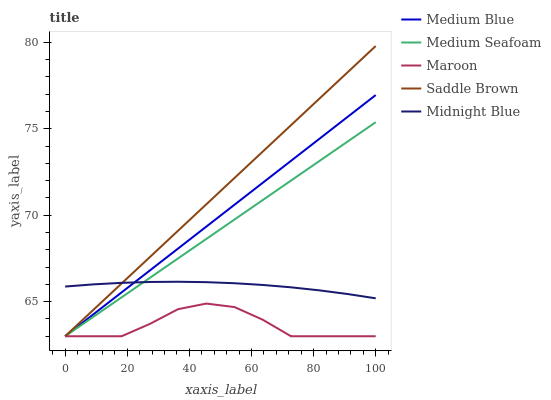Does Maroon have the minimum area under the curve?
Answer yes or no. Yes. Does Saddle Brown have the maximum area under the curve?
Answer yes or no. Yes. Does Medium Blue have the minimum area under the curve?
Answer yes or no. No. Does Medium Blue have the maximum area under the curve?
Answer yes or no. No. Is Medium Seafoam the smoothest?
Answer yes or no. Yes. Is Maroon the roughest?
Answer yes or no. Yes. Is Medium Blue the smoothest?
Answer yes or no. No. Is Medium Blue the roughest?
Answer yes or no. No. Does Saddle Brown have the highest value?
Answer yes or no. Yes. Does Medium Blue have the highest value?
Answer yes or no. No. Is Maroon less than Midnight Blue?
Answer yes or no. Yes. Is Midnight Blue greater than Maroon?
Answer yes or no. Yes. Does Maroon intersect Saddle Brown?
Answer yes or no. Yes. Is Maroon less than Saddle Brown?
Answer yes or no. No. Is Maroon greater than Saddle Brown?
Answer yes or no. No. Does Maroon intersect Midnight Blue?
Answer yes or no. No. 